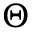<formula> <loc_0><loc_0><loc_500><loc_500>\Theta</formula> 